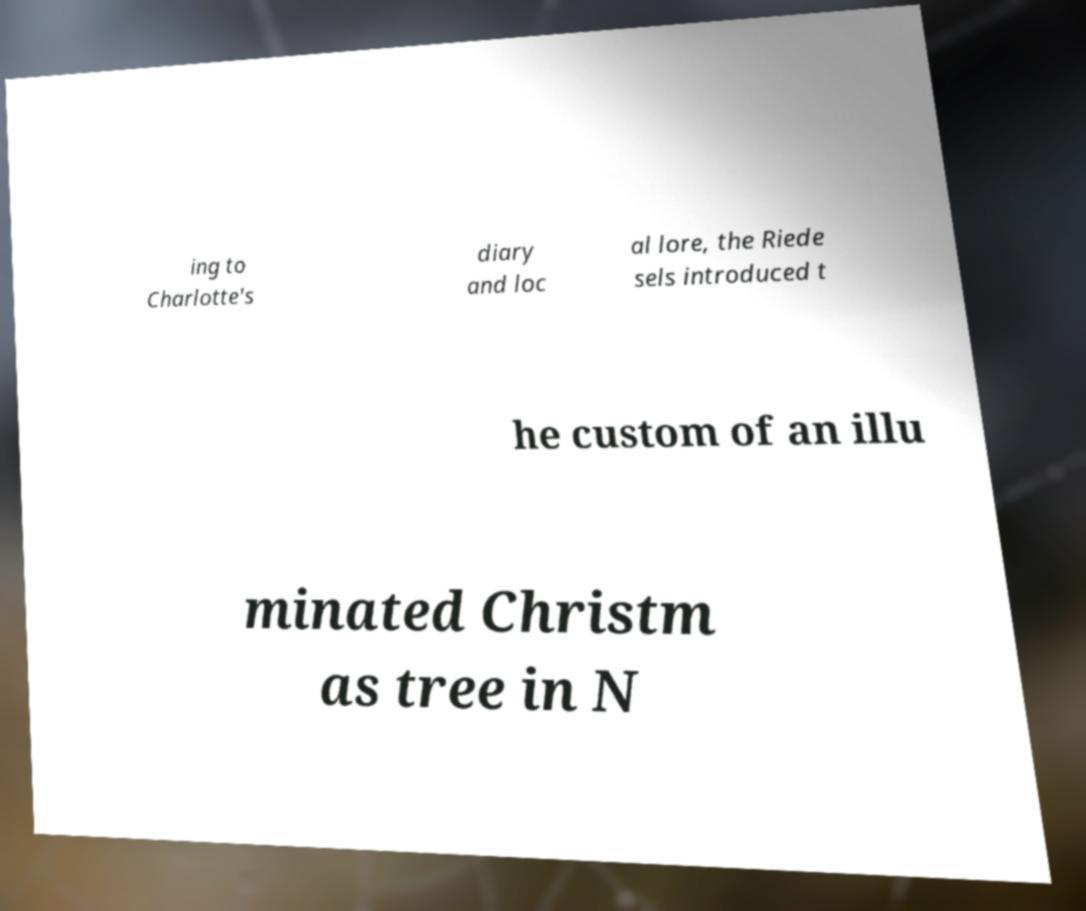Please identify and transcribe the text found in this image. ing to Charlotte's diary and loc al lore, the Riede sels introduced t he custom of an illu minated Christm as tree in N 